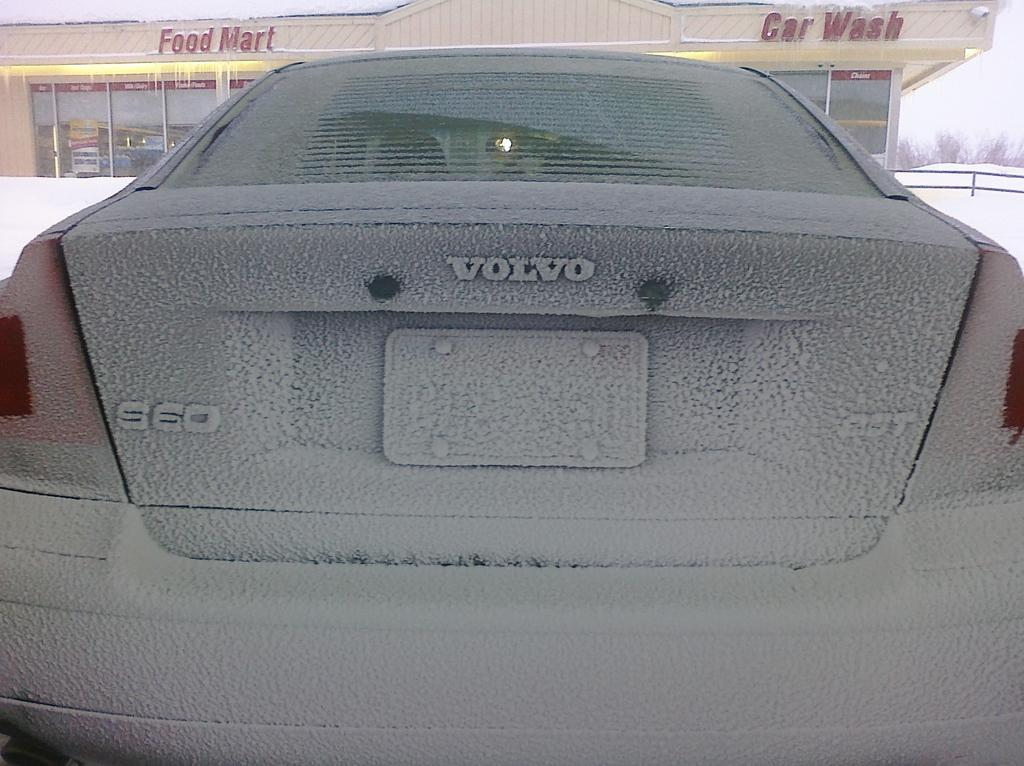What is the main subject of the image? There is a car in the image. How is the car affected by the weather in the image? The car is covered in snow. What can be seen in the background of the image? There is a building, trees, an iron railing, and the sky visible in the background of the image. What is written or displayed on the building? There is text on the building. What type of shoe can be seen performing a magic trick in the image? There is no shoe or magic trick present in the image. 